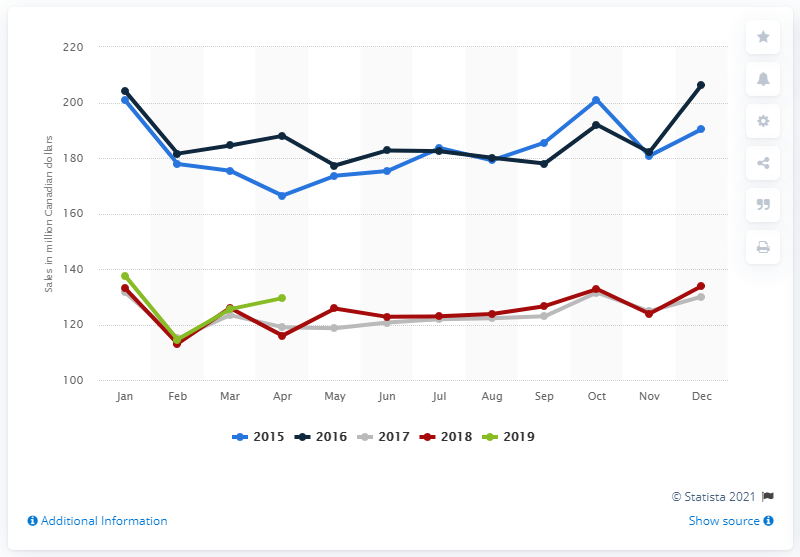Give some essential details in this illustration. In April 2019, the sales of over-the-counter drugs, vitamins, herbal remedies, and other health supplements at large retailers in Canada totaled 130.03 million Canadian dollars. 